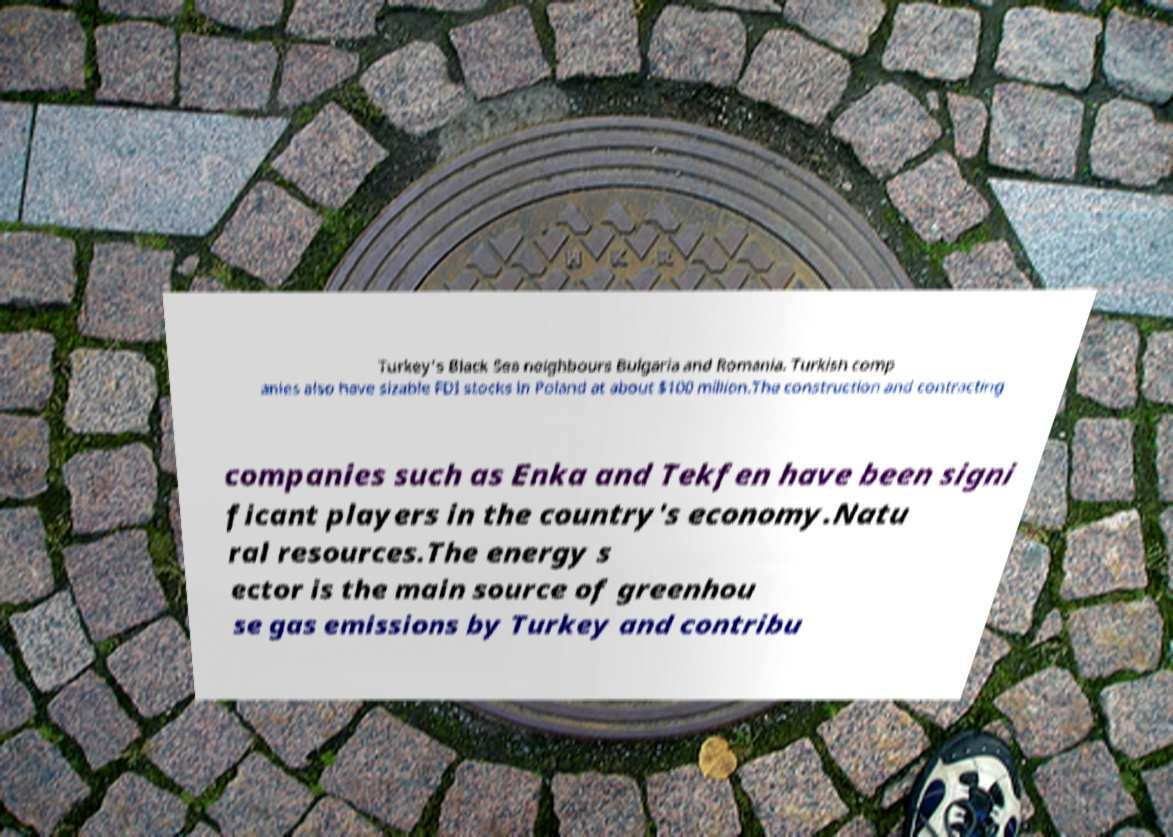Could you extract and type out the text from this image? Turkey's Black Sea neighbours Bulgaria and Romania. Turkish comp anies also have sizable FDI stocks in Poland at about $100 million.The construction and contracting companies such as Enka and Tekfen have been signi ficant players in the country's economy.Natu ral resources.The energy s ector is the main source of greenhou se gas emissions by Turkey and contribu 